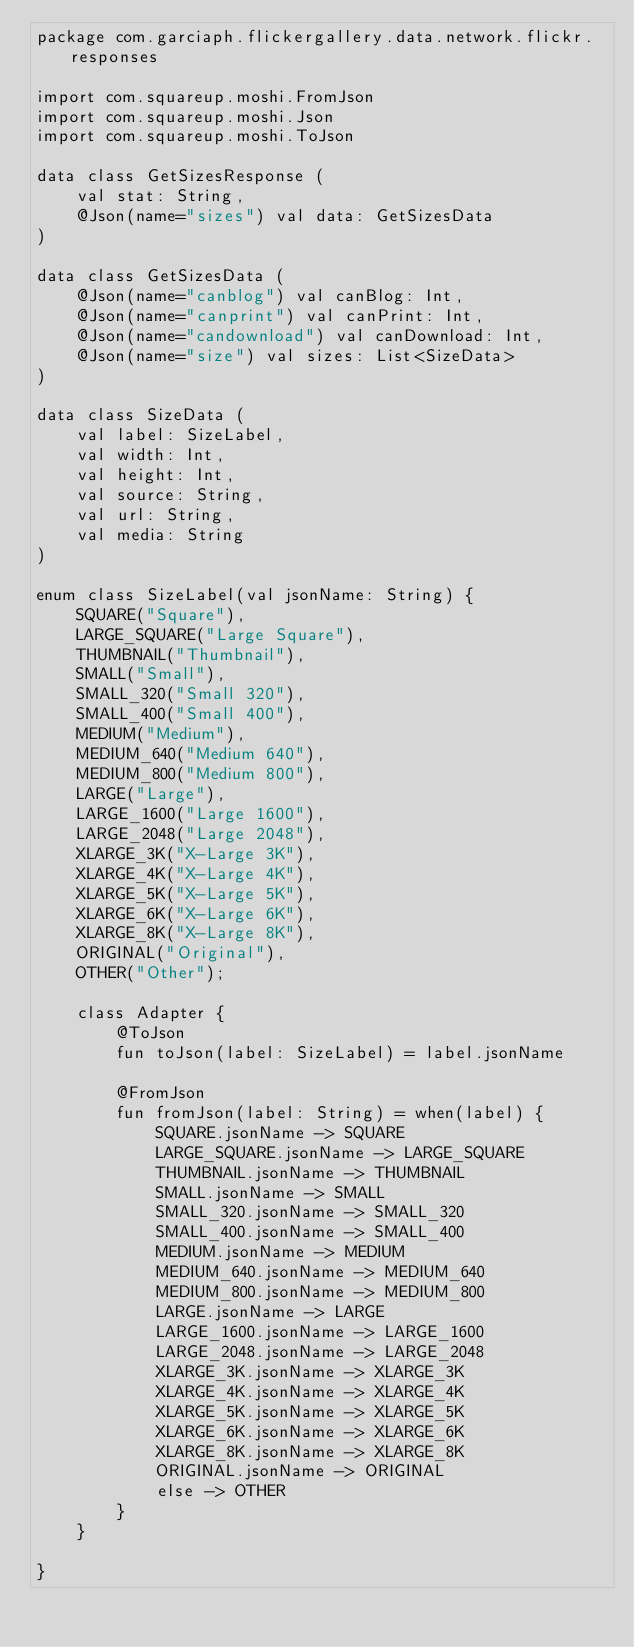Convert code to text. <code><loc_0><loc_0><loc_500><loc_500><_Kotlin_>package com.garciaph.flickergallery.data.network.flickr.responses

import com.squareup.moshi.FromJson
import com.squareup.moshi.Json
import com.squareup.moshi.ToJson

data class GetSizesResponse (
    val stat: String,
    @Json(name="sizes") val data: GetSizesData
)

data class GetSizesData (
    @Json(name="canblog") val canBlog: Int,
    @Json(name="canprint") val canPrint: Int,
    @Json(name="candownload") val canDownload: Int,
    @Json(name="size") val sizes: List<SizeData>
)

data class SizeData (
    val label: SizeLabel,
    val width: Int,
    val height: Int,
    val source: String,
    val url: String,
    val media: String
)

enum class SizeLabel(val jsonName: String) {
    SQUARE("Square"),
    LARGE_SQUARE("Large Square"),
    THUMBNAIL("Thumbnail"),
    SMALL("Small"),
    SMALL_320("Small 320"),
    SMALL_400("Small 400"),
    MEDIUM("Medium"),
    MEDIUM_640("Medium 640"),
    MEDIUM_800("Medium 800"),
    LARGE("Large"),
    LARGE_1600("Large 1600"),
    LARGE_2048("Large 2048"),
    XLARGE_3K("X-Large 3K"),
    XLARGE_4K("X-Large 4K"),
    XLARGE_5K("X-Large 5K"),
    XLARGE_6K("X-Large 6K"),
    XLARGE_8K("X-Large 8K"),
    ORIGINAL("Original"),
    OTHER("Other");

    class Adapter {
        @ToJson
        fun toJson(label: SizeLabel) = label.jsonName

        @FromJson
        fun fromJson(label: String) = when(label) {
            SQUARE.jsonName -> SQUARE
            LARGE_SQUARE.jsonName -> LARGE_SQUARE
            THUMBNAIL.jsonName -> THUMBNAIL
            SMALL.jsonName -> SMALL
            SMALL_320.jsonName -> SMALL_320
            SMALL_400.jsonName -> SMALL_400
            MEDIUM.jsonName -> MEDIUM
            MEDIUM_640.jsonName -> MEDIUM_640
            MEDIUM_800.jsonName -> MEDIUM_800
            LARGE.jsonName -> LARGE
            LARGE_1600.jsonName -> LARGE_1600
            LARGE_2048.jsonName -> LARGE_2048
            XLARGE_3K.jsonName -> XLARGE_3K
            XLARGE_4K.jsonName -> XLARGE_4K
            XLARGE_5K.jsonName -> XLARGE_5K
            XLARGE_6K.jsonName -> XLARGE_6K
            XLARGE_8K.jsonName -> XLARGE_8K
            ORIGINAL.jsonName -> ORIGINAL
            else -> OTHER
        }
    }

}

</code> 